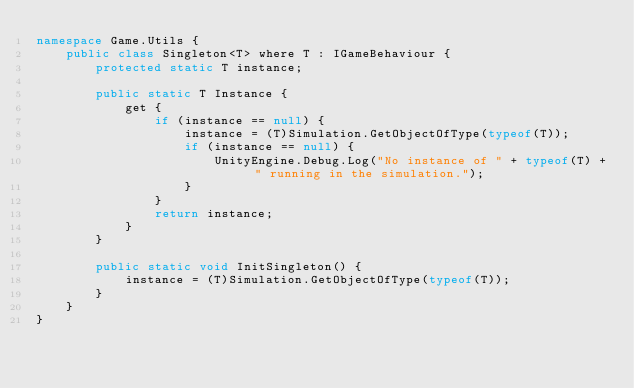<code> <loc_0><loc_0><loc_500><loc_500><_C#_>namespace Game.Utils {
    public class Singleton<T> where T : IGameBehaviour {
        protected static T instance;

        public static T Instance {
            get {
                if (instance == null) {
                    instance = (T)Simulation.GetObjectOfType(typeof(T));
                    if (instance == null) {
                        UnityEngine.Debug.Log("No instance of " + typeof(T) + " running in the simulation.");
                    }
                }
                return instance;
            }
        }

        public static void InitSingleton() {
            instance = (T)Simulation.GetObjectOfType(typeof(T));
        }
    }
}
</code> 